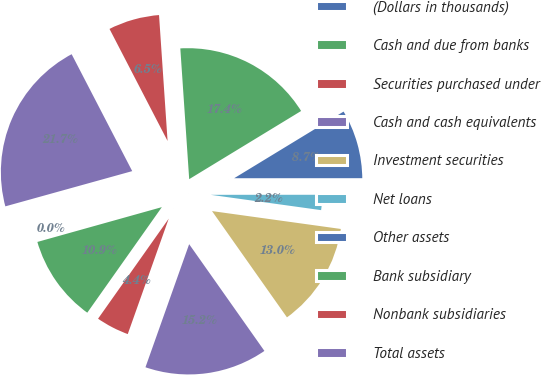Convert chart to OTSL. <chart><loc_0><loc_0><loc_500><loc_500><pie_chart><fcel>(Dollars in thousands)<fcel>Cash and due from banks<fcel>Securities purchased under<fcel>Cash and cash equivalents<fcel>Investment securities<fcel>Net loans<fcel>Other assets<fcel>Bank subsidiary<fcel>Nonbank subsidiaries<fcel>Total assets<nl><fcel>0.03%<fcel>10.87%<fcel>4.36%<fcel>15.2%<fcel>13.03%<fcel>2.2%<fcel>8.7%<fcel>17.37%<fcel>6.53%<fcel>21.7%<nl></chart> 